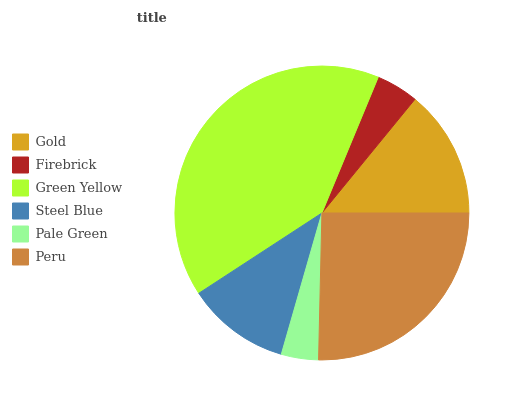Is Pale Green the minimum?
Answer yes or no. Yes. Is Green Yellow the maximum?
Answer yes or no. Yes. Is Firebrick the minimum?
Answer yes or no. No. Is Firebrick the maximum?
Answer yes or no. No. Is Gold greater than Firebrick?
Answer yes or no. Yes. Is Firebrick less than Gold?
Answer yes or no. Yes. Is Firebrick greater than Gold?
Answer yes or no. No. Is Gold less than Firebrick?
Answer yes or no. No. Is Gold the high median?
Answer yes or no. Yes. Is Steel Blue the low median?
Answer yes or no. Yes. Is Steel Blue the high median?
Answer yes or no. No. Is Pale Green the low median?
Answer yes or no. No. 